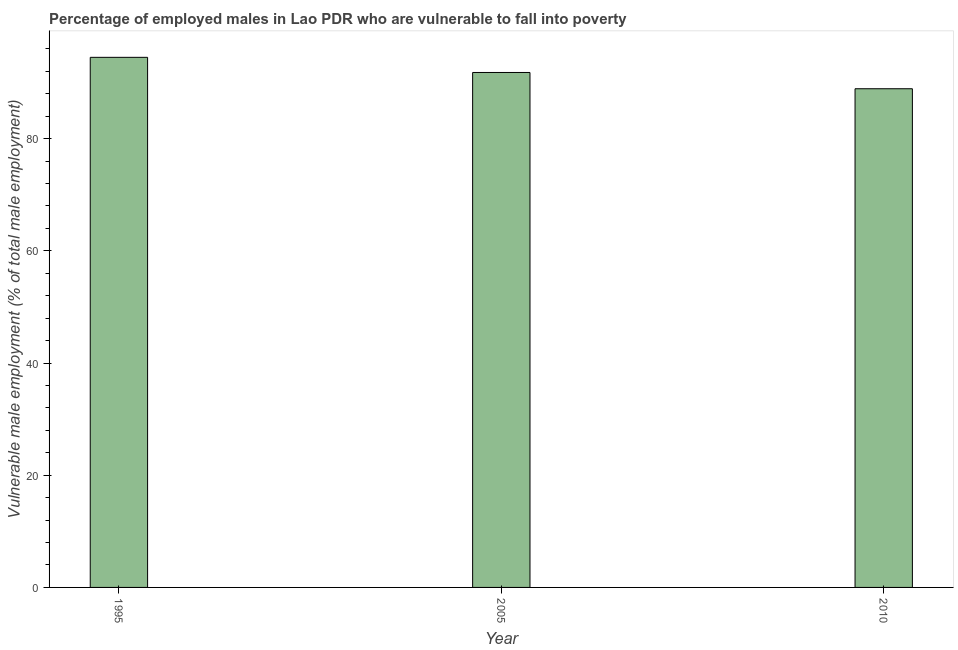What is the title of the graph?
Your response must be concise. Percentage of employed males in Lao PDR who are vulnerable to fall into poverty. What is the label or title of the Y-axis?
Your answer should be compact. Vulnerable male employment (% of total male employment). What is the percentage of employed males who are vulnerable to fall into poverty in 2010?
Ensure brevity in your answer.  88.9. Across all years, what is the maximum percentage of employed males who are vulnerable to fall into poverty?
Give a very brief answer. 94.5. Across all years, what is the minimum percentage of employed males who are vulnerable to fall into poverty?
Ensure brevity in your answer.  88.9. In which year was the percentage of employed males who are vulnerable to fall into poverty minimum?
Ensure brevity in your answer.  2010. What is the sum of the percentage of employed males who are vulnerable to fall into poverty?
Your answer should be compact. 275.2. What is the difference between the percentage of employed males who are vulnerable to fall into poverty in 1995 and 2010?
Provide a succinct answer. 5.6. What is the average percentage of employed males who are vulnerable to fall into poverty per year?
Your answer should be very brief. 91.73. What is the median percentage of employed males who are vulnerable to fall into poverty?
Offer a very short reply. 91.8. In how many years, is the percentage of employed males who are vulnerable to fall into poverty greater than 16 %?
Provide a succinct answer. 3. Do a majority of the years between 1995 and 2010 (inclusive) have percentage of employed males who are vulnerable to fall into poverty greater than 88 %?
Provide a short and direct response. Yes. What is the ratio of the percentage of employed males who are vulnerable to fall into poverty in 1995 to that in 2010?
Offer a terse response. 1.06. Is the difference between the percentage of employed males who are vulnerable to fall into poverty in 1995 and 2010 greater than the difference between any two years?
Offer a very short reply. Yes. What is the difference between the highest and the second highest percentage of employed males who are vulnerable to fall into poverty?
Your answer should be compact. 2.7. Is the sum of the percentage of employed males who are vulnerable to fall into poverty in 2005 and 2010 greater than the maximum percentage of employed males who are vulnerable to fall into poverty across all years?
Your answer should be very brief. Yes. What is the difference between the highest and the lowest percentage of employed males who are vulnerable to fall into poverty?
Offer a very short reply. 5.6. How many bars are there?
Offer a very short reply. 3. Are all the bars in the graph horizontal?
Offer a very short reply. No. How many years are there in the graph?
Keep it short and to the point. 3. What is the difference between two consecutive major ticks on the Y-axis?
Your answer should be very brief. 20. Are the values on the major ticks of Y-axis written in scientific E-notation?
Keep it short and to the point. No. What is the Vulnerable male employment (% of total male employment) of 1995?
Offer a terse response. 94.5. What is the Vulnerable male employment (% of total male employment) in 2005?
Your response must be concise. 91.8. What is the Vulnerable male employment (% of total male employment) of 2010?
Offer a very short reply. 88.9. What is the difference between the Vulnerable male employment (% of total male employment) in 1995 and 2010?
Give a very brief answer. 5.6. What is the ratio of the Vulnerable male employment (% of total male employment) in 1995 to that in 2010?
Provide a succinct answer. 1.06. What is the ratio of the Vulnerable male employment (% of total male employment) in 2005 to that in 2010?
Your response must be concise. 1.03. 